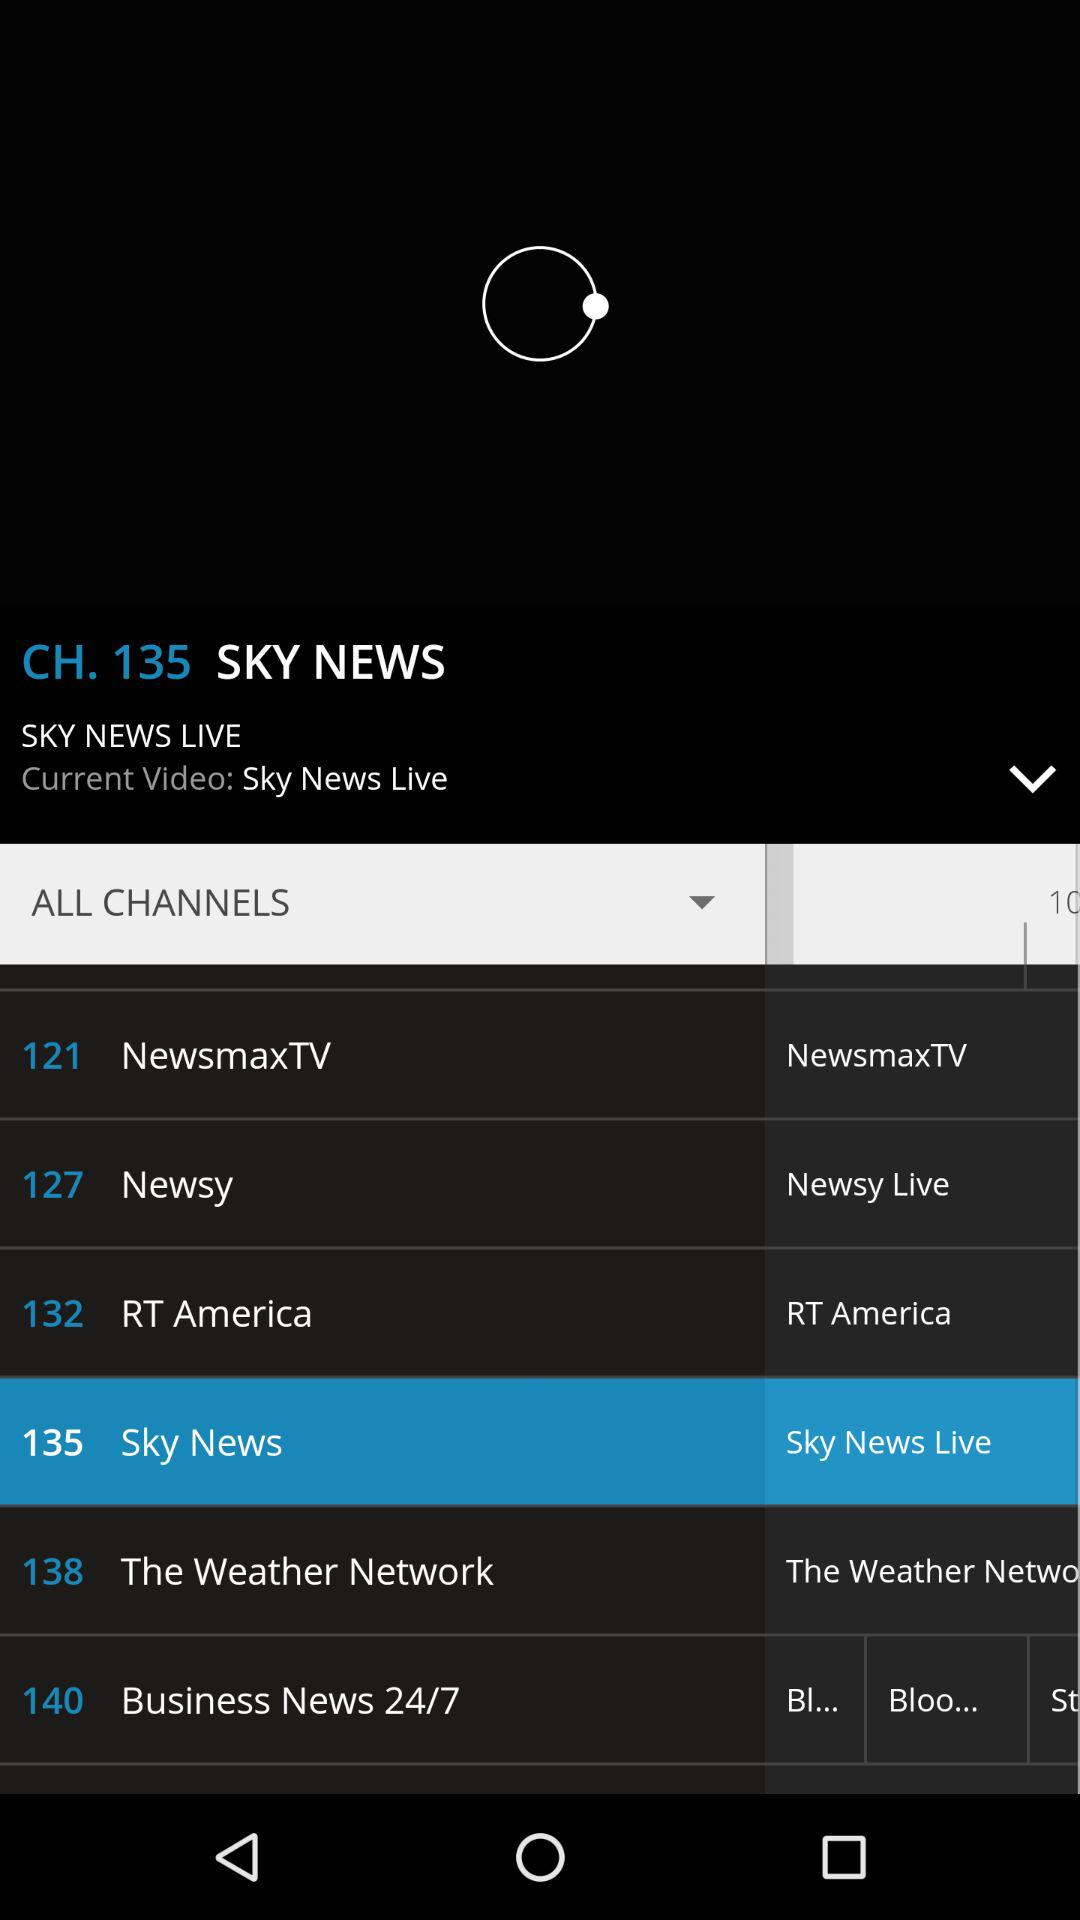What is the current video? The current video is "Sky News Live". 